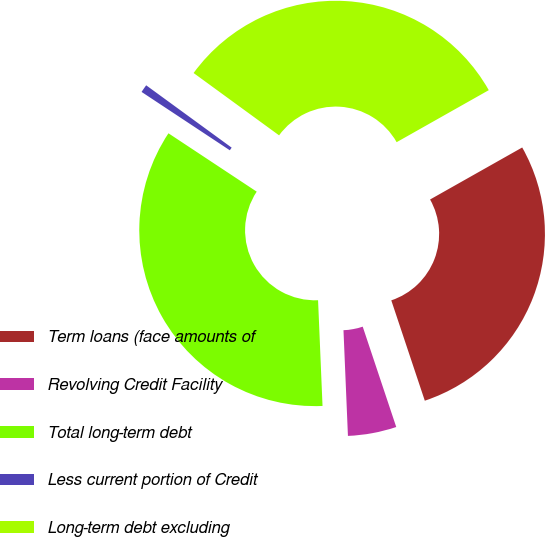Convert chart. <chart><loc_0><loc_0><loc_500><loc_500><pie_chart><fcel>Term loans (face amounts of<fcel>Revolving Credit Facility<fcel>Total long-term debt<fcel>Less current portion of Credit<fcel>Long-term debt excluding<nl><fcel>28.05%<fcel>4.46%<fcel>34.97%<fcel>0.73%<fcel>31.79%<nl></chart> 